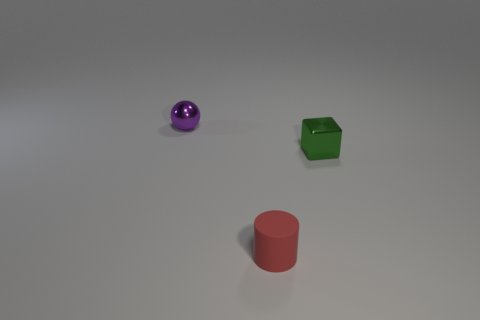Are there any purple things of the same shape as the red rubber thing?
Offer a very short reply. No. What is the shape of the small red rubber object?
Your answer should be compact. Cylinder. Is the number of tiny red rubber objects right of the small block greater than the number of tiny metallic cubes left of the tiny red rubber cylinder?
Keep it short and to the point. No. What number of other things are there of the same size as the green metallic block?
Make the answer very short. 2. What is the thing that is both on the left side of the green block and behind the matte cylinder made of?
Provide a succinct answer. Metal. There is a thing left of the tiny rubber object that is in front of the green object; what number of red objects are left of it?
Offer a very short reply. 0. Are there any other things that are the same color as the tiny matte thing?
Provide a short and direct response. No. How many things are behind the cylinder and in front of the small purple shiny ball?
Provide a short and direct response. 1. There is a thing in front of the shiny block; is its size the same as the thing behind the small green metallic cube?
Ensure brevity in your answer.  Yes. What number of things are either small metallic things to the right of the tiny sphere or big red shiny balls?
Keep it short and to the point. 1. 